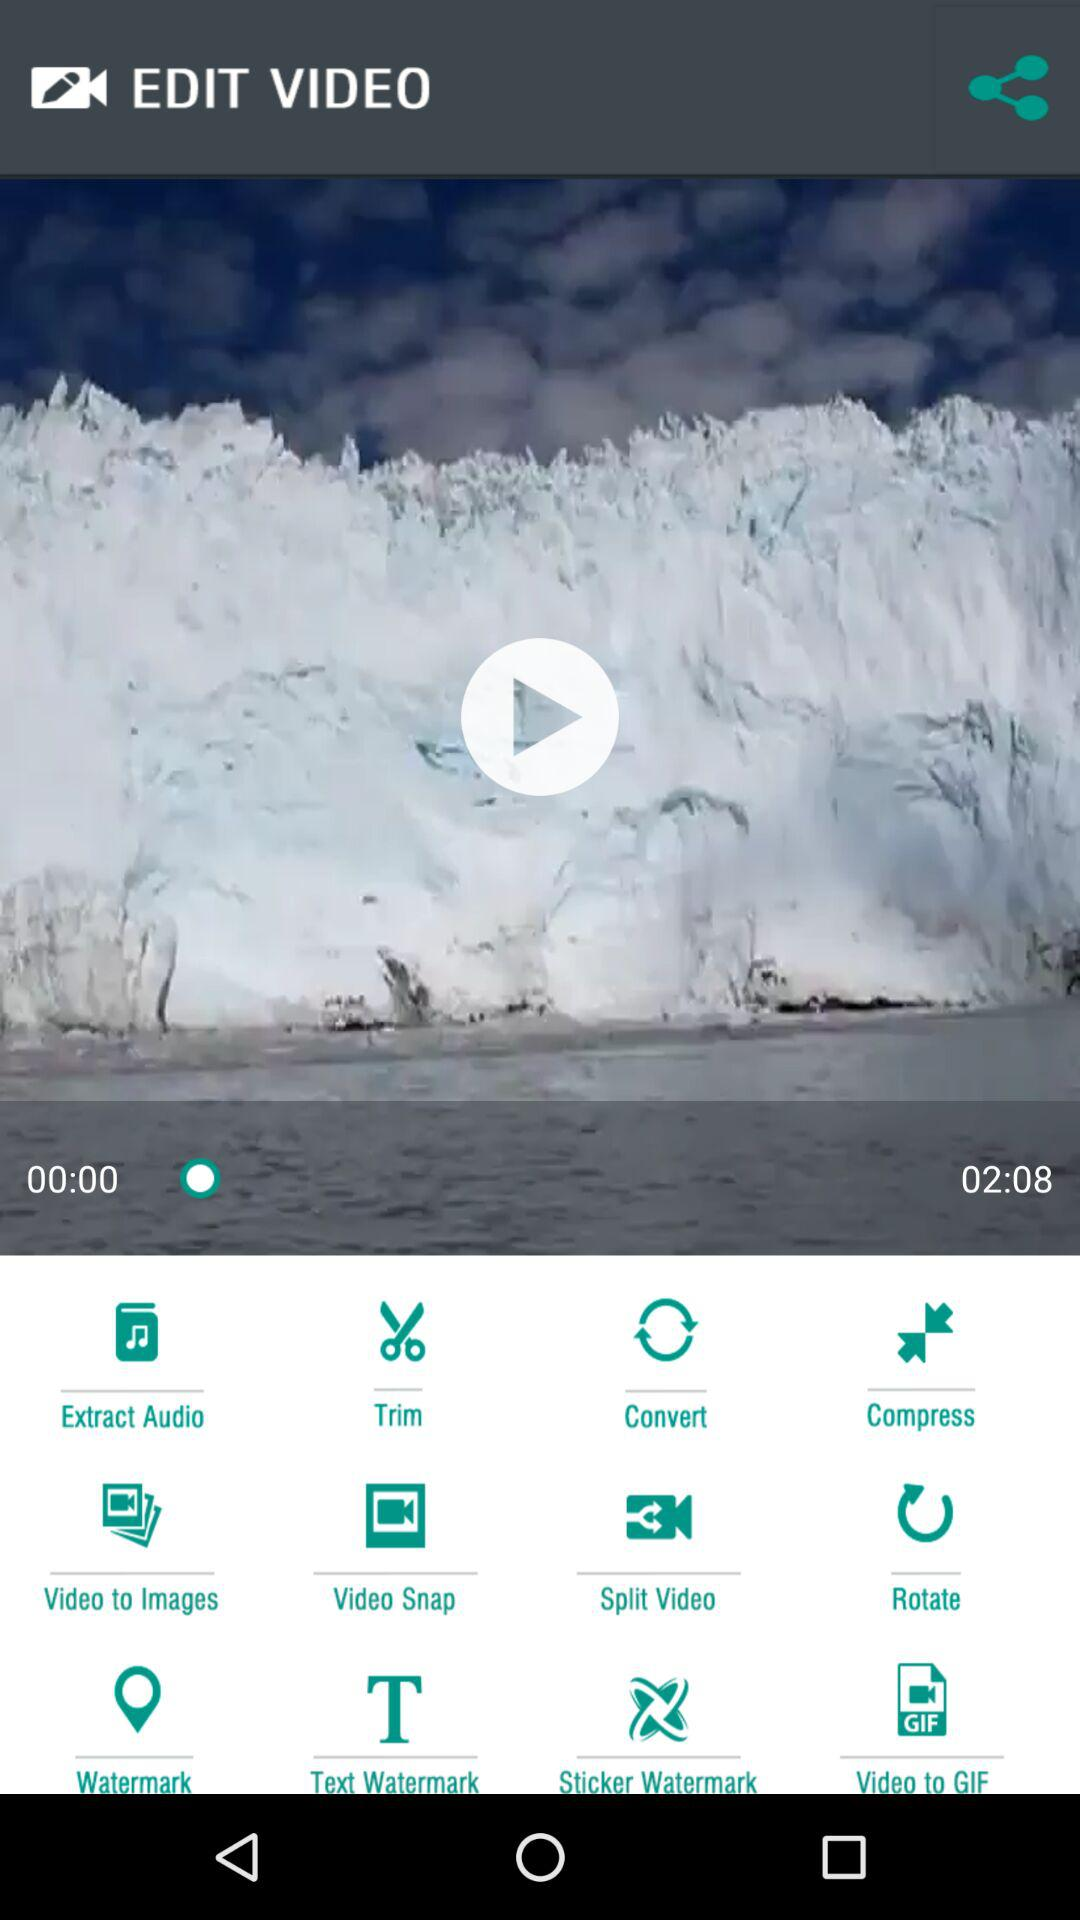What is the duration of the video? The duration of the videos is 2 minutes and 8 seconds. 